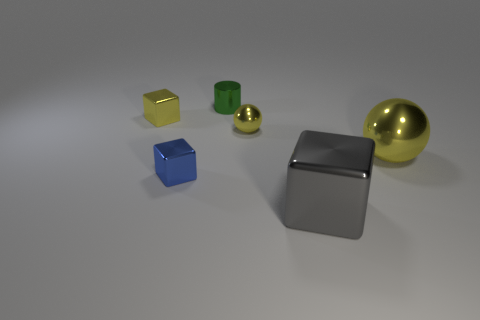Add 2 red shiny things. How many objects exist? 8 Subtract all big shiny cubes. How many cubes are left? 2 Subtract all gray cubes. How many cubes are left? 2 Subtract all cylinders. How many objects are left? 5 Add 6 tiny blue shiny blocks. How many tiny blue shiny blocks exist? 7 Subtract 0 blue cylinders. How many objects are left? 6 Subtract all red balls. Subtract all cyan blocks. How many balls are left? 2 Subtract all tiny yellow metallic spheres. Subtract all purple rubber cubes. How many objects are left? 5 Add 6 small blue metal things. How many small blue metal things are left? 7 